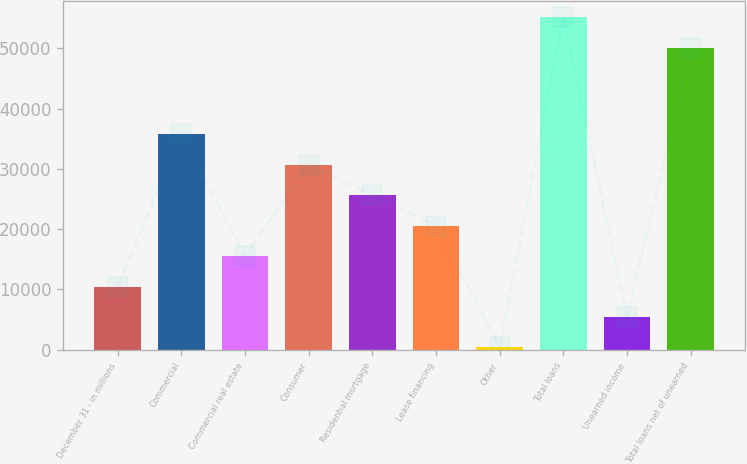<chart> <loc_0><loc_0><loc_500><loc_500><bar_chart><fcel>December 31 - in millions<fcel>Commercial<fcel>Commercial real estate<fcel>Consumer<fcel>Residential mortgage<fcel>Lease financing<fcel>Other<fcel>Total loans<fcel>Unearned income<fcel>Total loans net of unearned<nl><fcel>10480.8<fcel>35742.8<fcel>15533.2<fcel>30690.4<fcel>25638<fcel>20585.6<fcel>376<fcel>55157.4<fcel>5428.4<fcel>50105<nl></chart> 